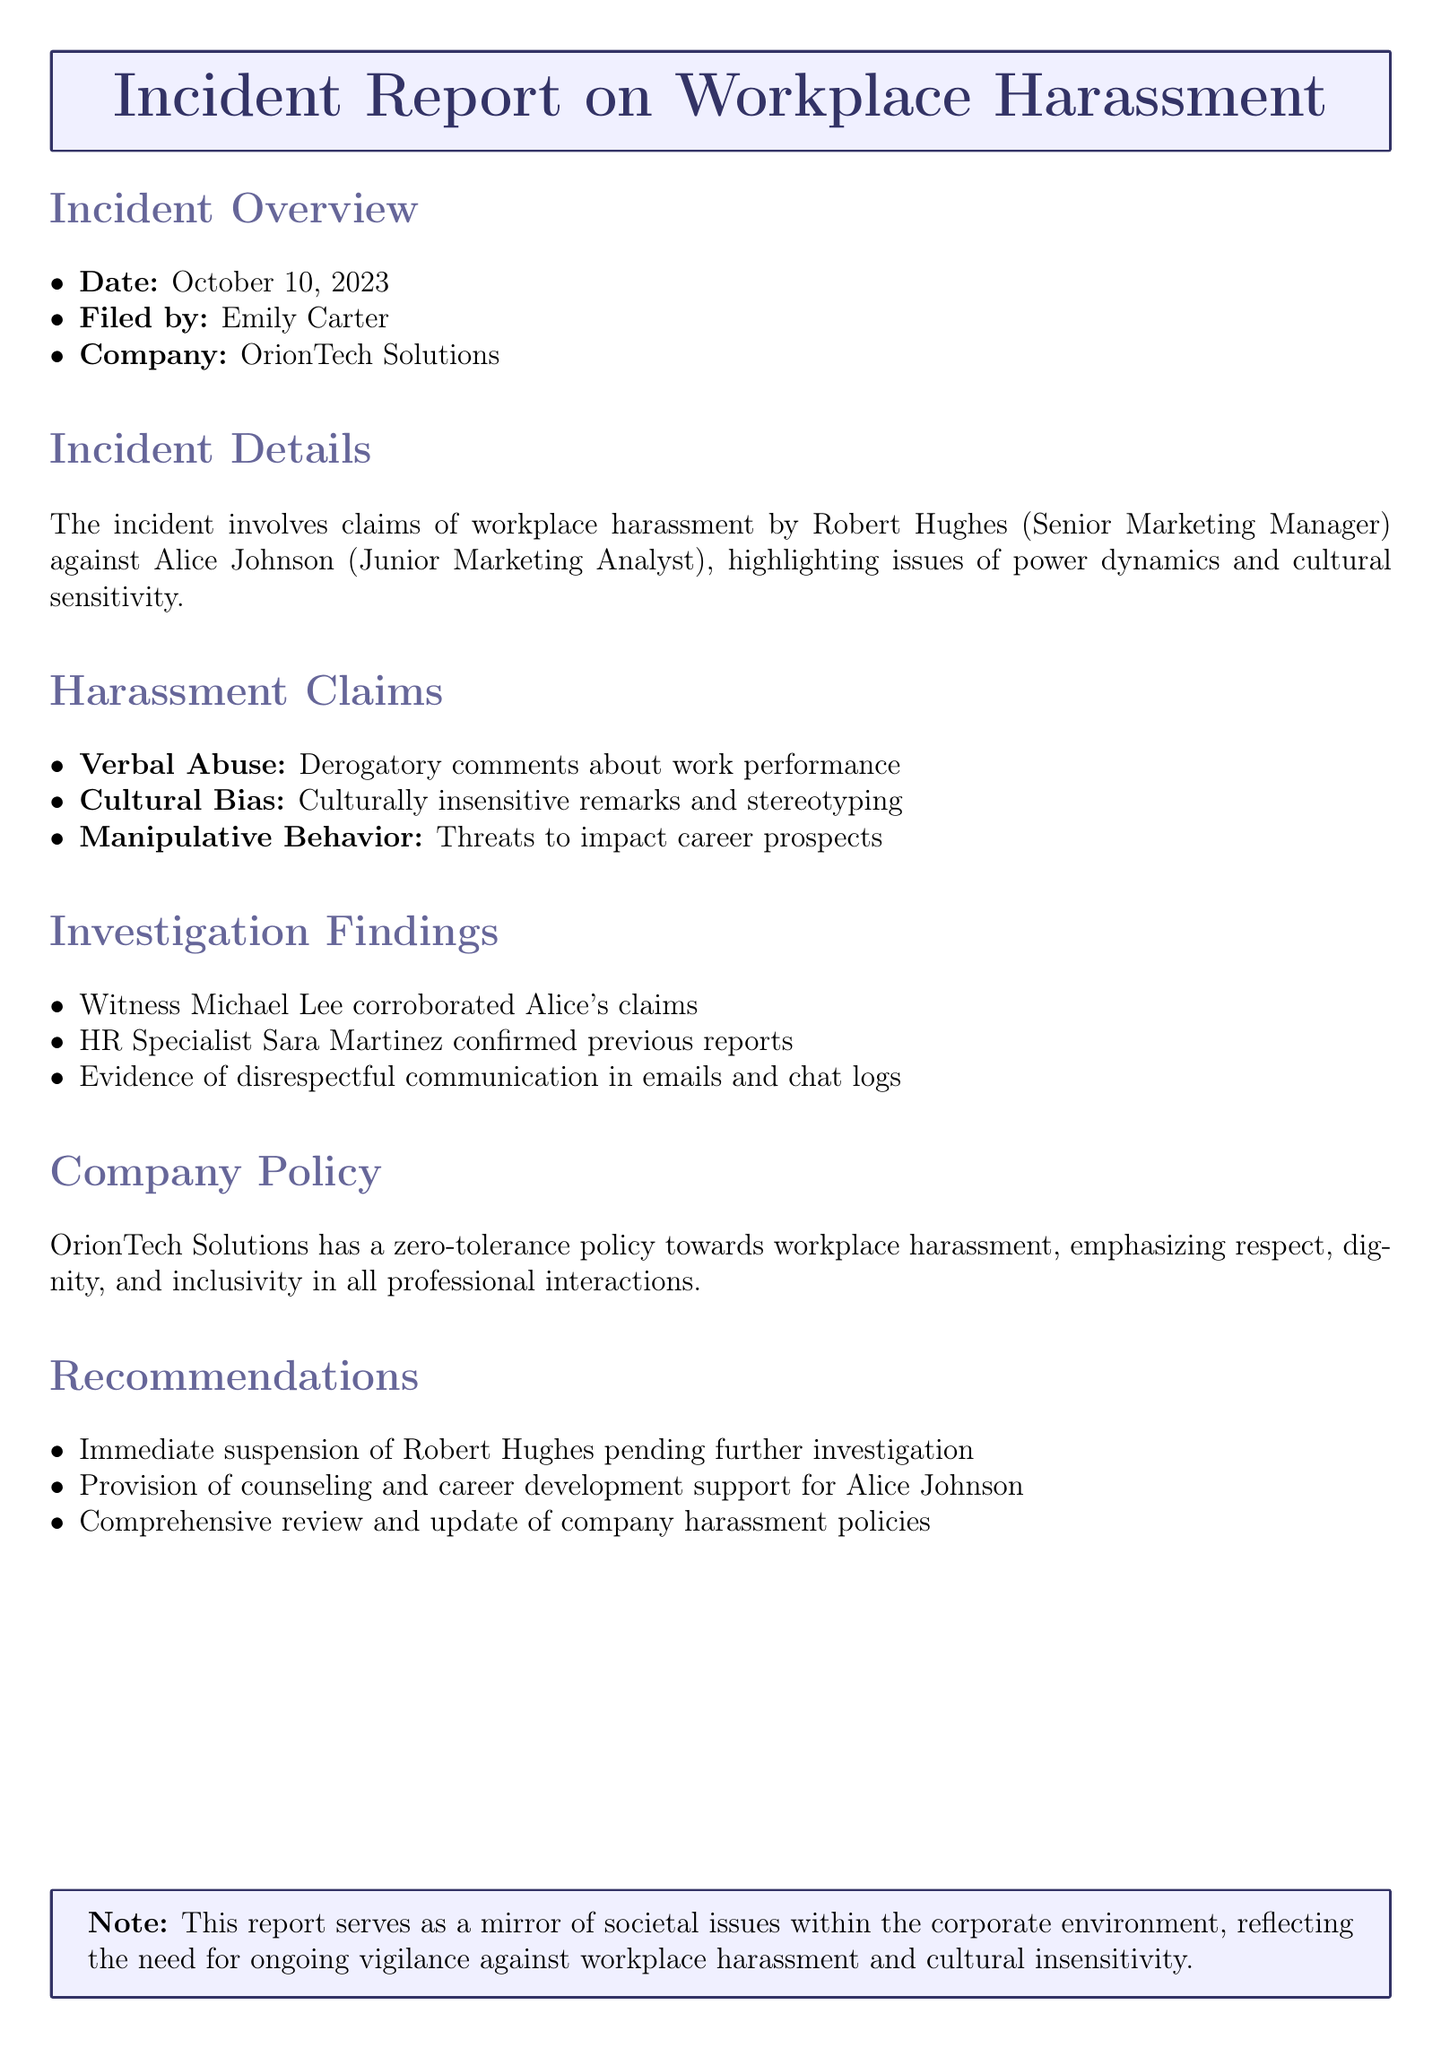What is the date of the incident? The date is stated in the incident overview section as October 10, 2023.
Answer: October 10, 2023 Who filed the incident report? The document specifies that the report was filed by Emily Carter.
Answer: Emily Carter What is the role of Robert Hughes? The document identifies Robert Hughes as the Senior Marketing Manager involved in the incident.
Answer: Senior Marketing Manager What behavior is classified as "Cultural Bias"? The report describes culturally insensitive remarks and stereotyping as examples of cultural bias.
Answer: Culturally insensitive remarks and stereotyping How many witnesses corroborated Alice's claims? According to the investigation findings, one witness, Michael Lee, corroborated Alice's claims.
Answer: One What is the company's stance on workplace harassment? The company policy emphasizes a zero-tolerance approach to workplace harassment.
Answer: Zero-tolerance policy What recommendation was made for Alice Johnson? The document recommends providing counseling and career development support for Alice Johnson.
Answer: Counseling and career development support What specific action is recommended for Robert Hughes? The recommendations include the immediate suspension of Robert Hughes pending further investigation.
Answer: Immediate suspension What is the purpose of this report? The note at the end indicates that the report serves as a mirror of societal issues within the corporate environment.
Answer: Mirror of societal issues 